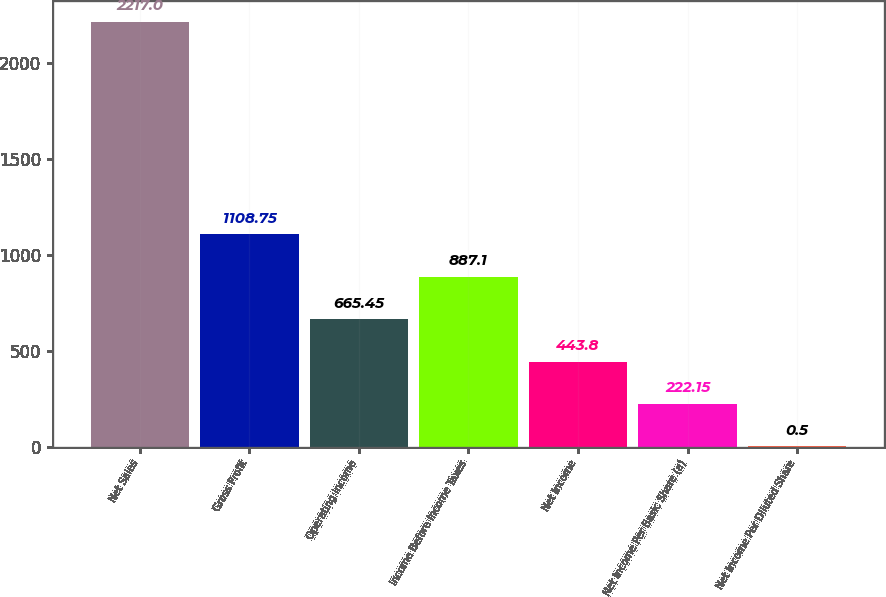Convert chart to OTSL. <chart><loc_0><loc_0><loc_500><loc_500><bar_chart><fcel>Net Sales<fcel>Gross Profit<fcel>Operating Income<fcel>Income Before Income Taxes<fcel>Net Income<fcel>Net Income Per Basic Share (a)<fcel>Net Income Per Diluted Share<nl><fcel>2217<fcel>1108.75<fcel>665.45<fcel>887.1<fcel>443.8<fcel>222.15<fcel>0.5<nl></chart> 